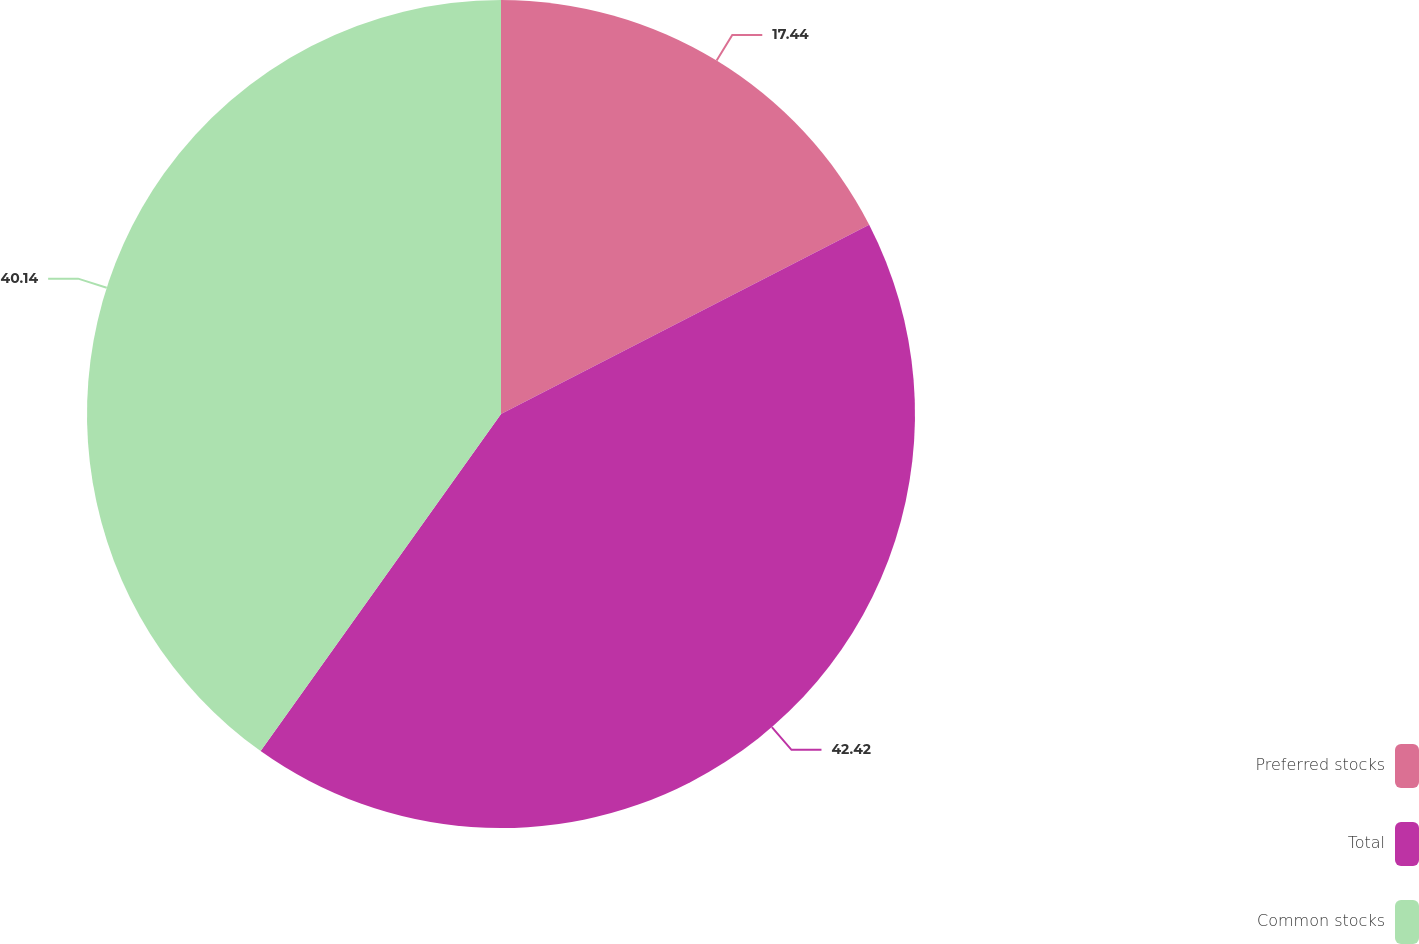Convert chart. <chart><loc_0><loc_0><loc_500><loc_500><pie_chart><fcel>Preferred stocks<fcel>Total<fcel>Common stocks<nl><fcel>17.44%<fcel>42.42%<fcel>40.14%<nl></chart> 